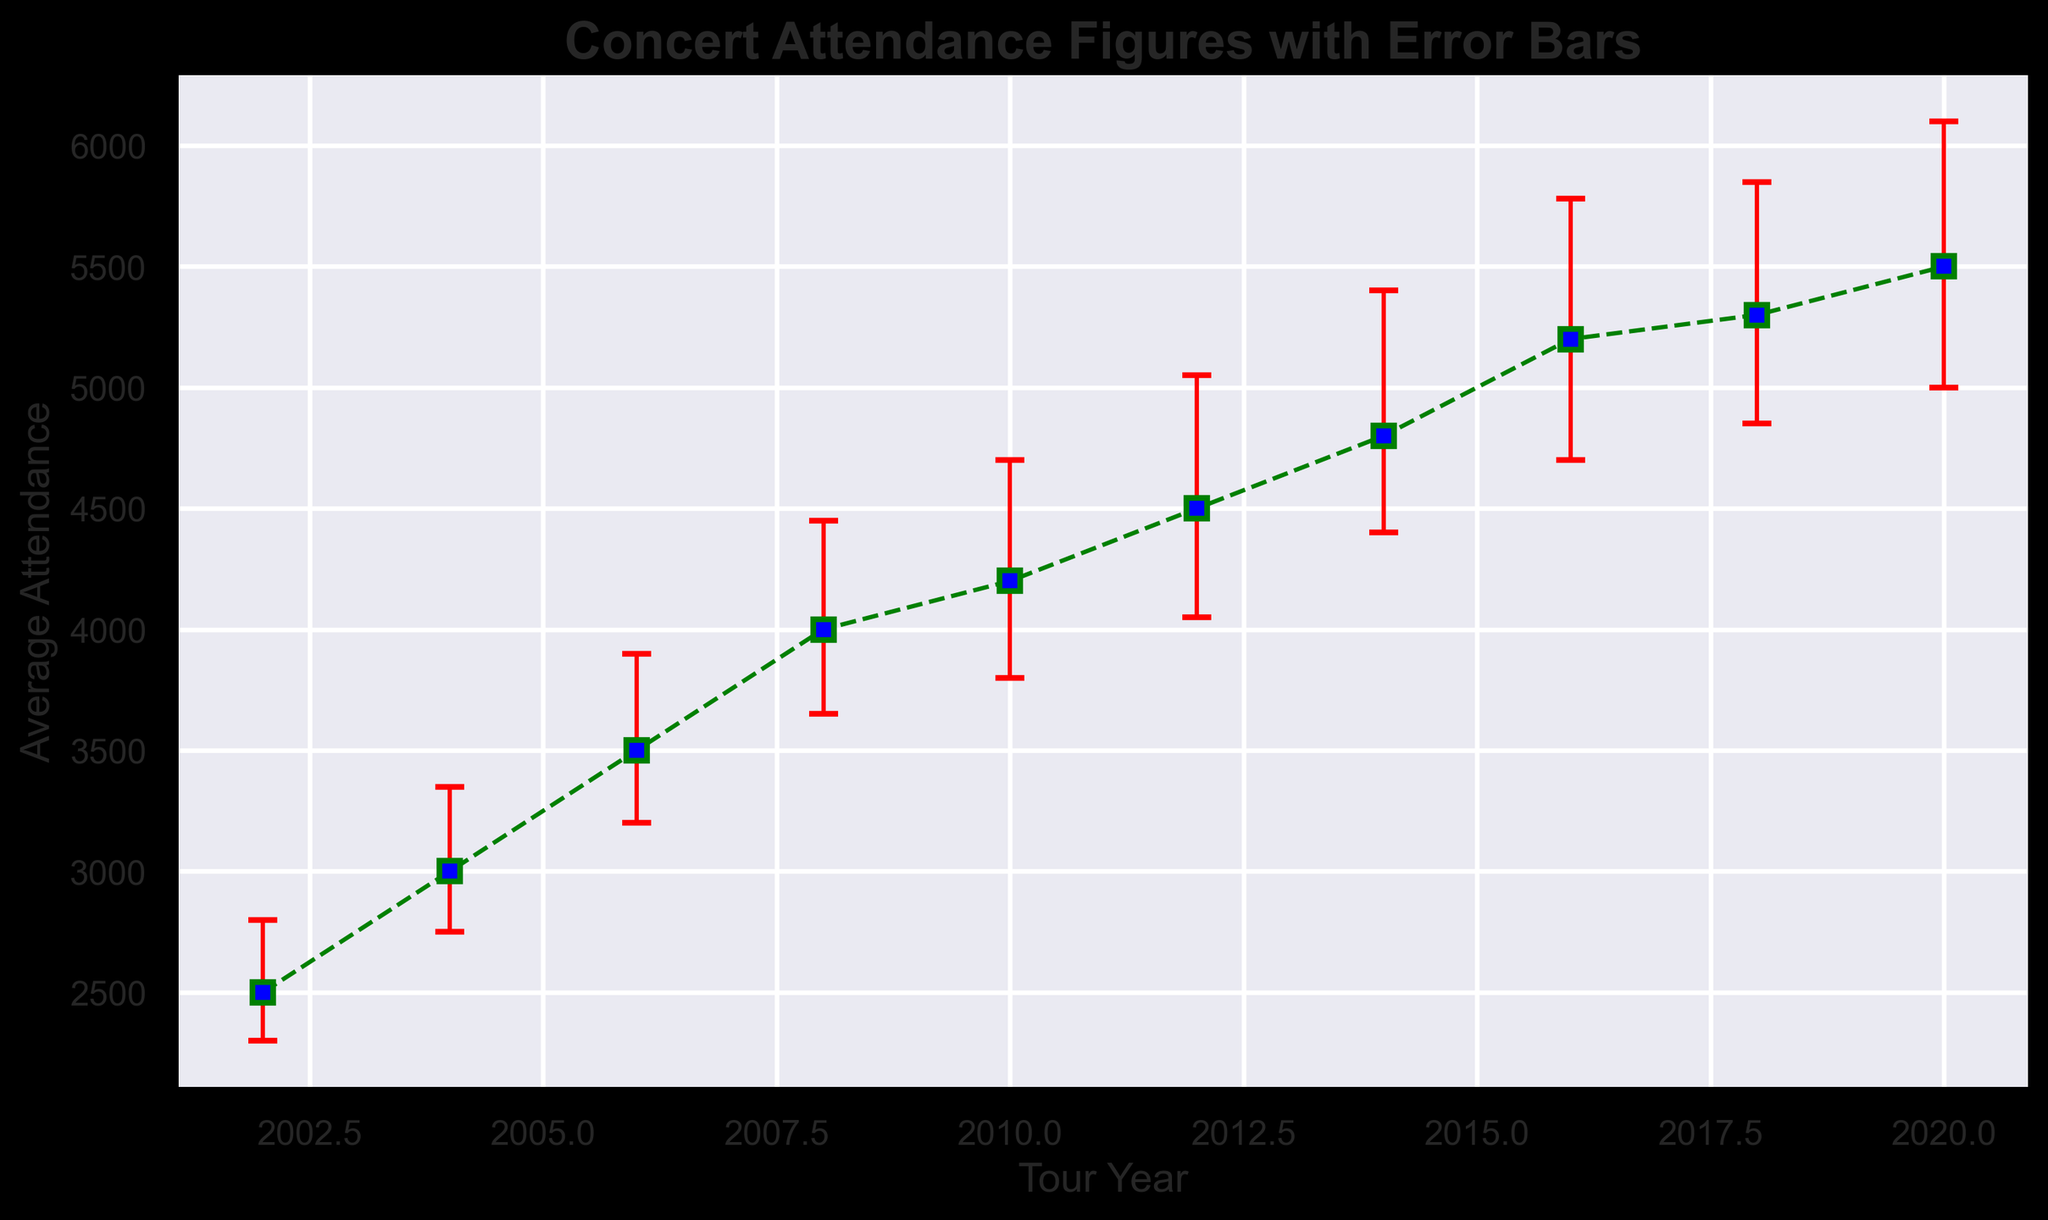What is the average attendance for the tour year 2012? The data list shows that the average attendance for the tour year 2012 is directly listed as 4500.
Answer: 4500 Which tour year had the highest average attendance? By looking at the average attendance values, the highest value is in the year 2020 with 5500 average attendance.
Answer: 2020 In which tour year was the error range the largest? The error range is calculated by adding the lower error and upper error values. For the year 2014, the error range is 400 + 600 = 1000, which is the largest among all tour years.
Answer: 2014 By how much did the average attendance increase from 2002 to 2020? The average attendance in 2002 is 2500, and in 2020 it is 5500. The increase is calculated by 5500 - 2500 = 3000.
Answer: 3000 Which tour year had the smallest error range? The smallest error range can be found by comparing the (lower + upper) error values. The year 2002 has an error range of 200 + 300 = 500, which is the smallest among all tour years.
Answer: 2002 What is the average of average attendances from 2002 to 2012? Add the average attendances for the years 2002, 2004, 2006, 2008, 2010, and 2012 and divide by the number of years: (2500 + 3000 + 3500 + 4000 + 4200 + 4500)/6 = 21100/6 = 3516.67.
Answer: 3516.67 Is the average attendance in 2014 greater than in 2012? By comparing the values, average attendance in 2014 is 4800, and in 2012, it is 4500. 4800 is greater than 4500.
Answer: Yes What is the average of the lower errors from 2010 to 2020? Add the lower error bars for the years 2010, 2012, 2014, 2016, 2018, and 2020, then divide by 6: (400 + 450 + 400 + 500 + 450 + 500)/6 = 2700/6 = 450.
Answer: 450 Compare the error bars in 2016: Is the upper error larger than the lower error? The upper error in 2016 is 580, while the lower error is 500. 580 is larger than 500.
Answer: Yes What is the total error range (lower + upper) for the year 2008? The lower error for 2008 is 350 and the upper error is 450. The total error range is 350 + 450 = 800.
Answer: 800 